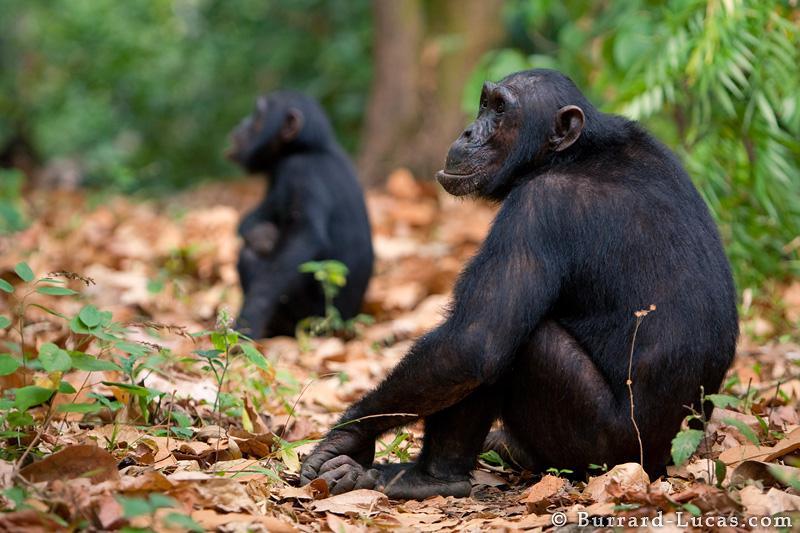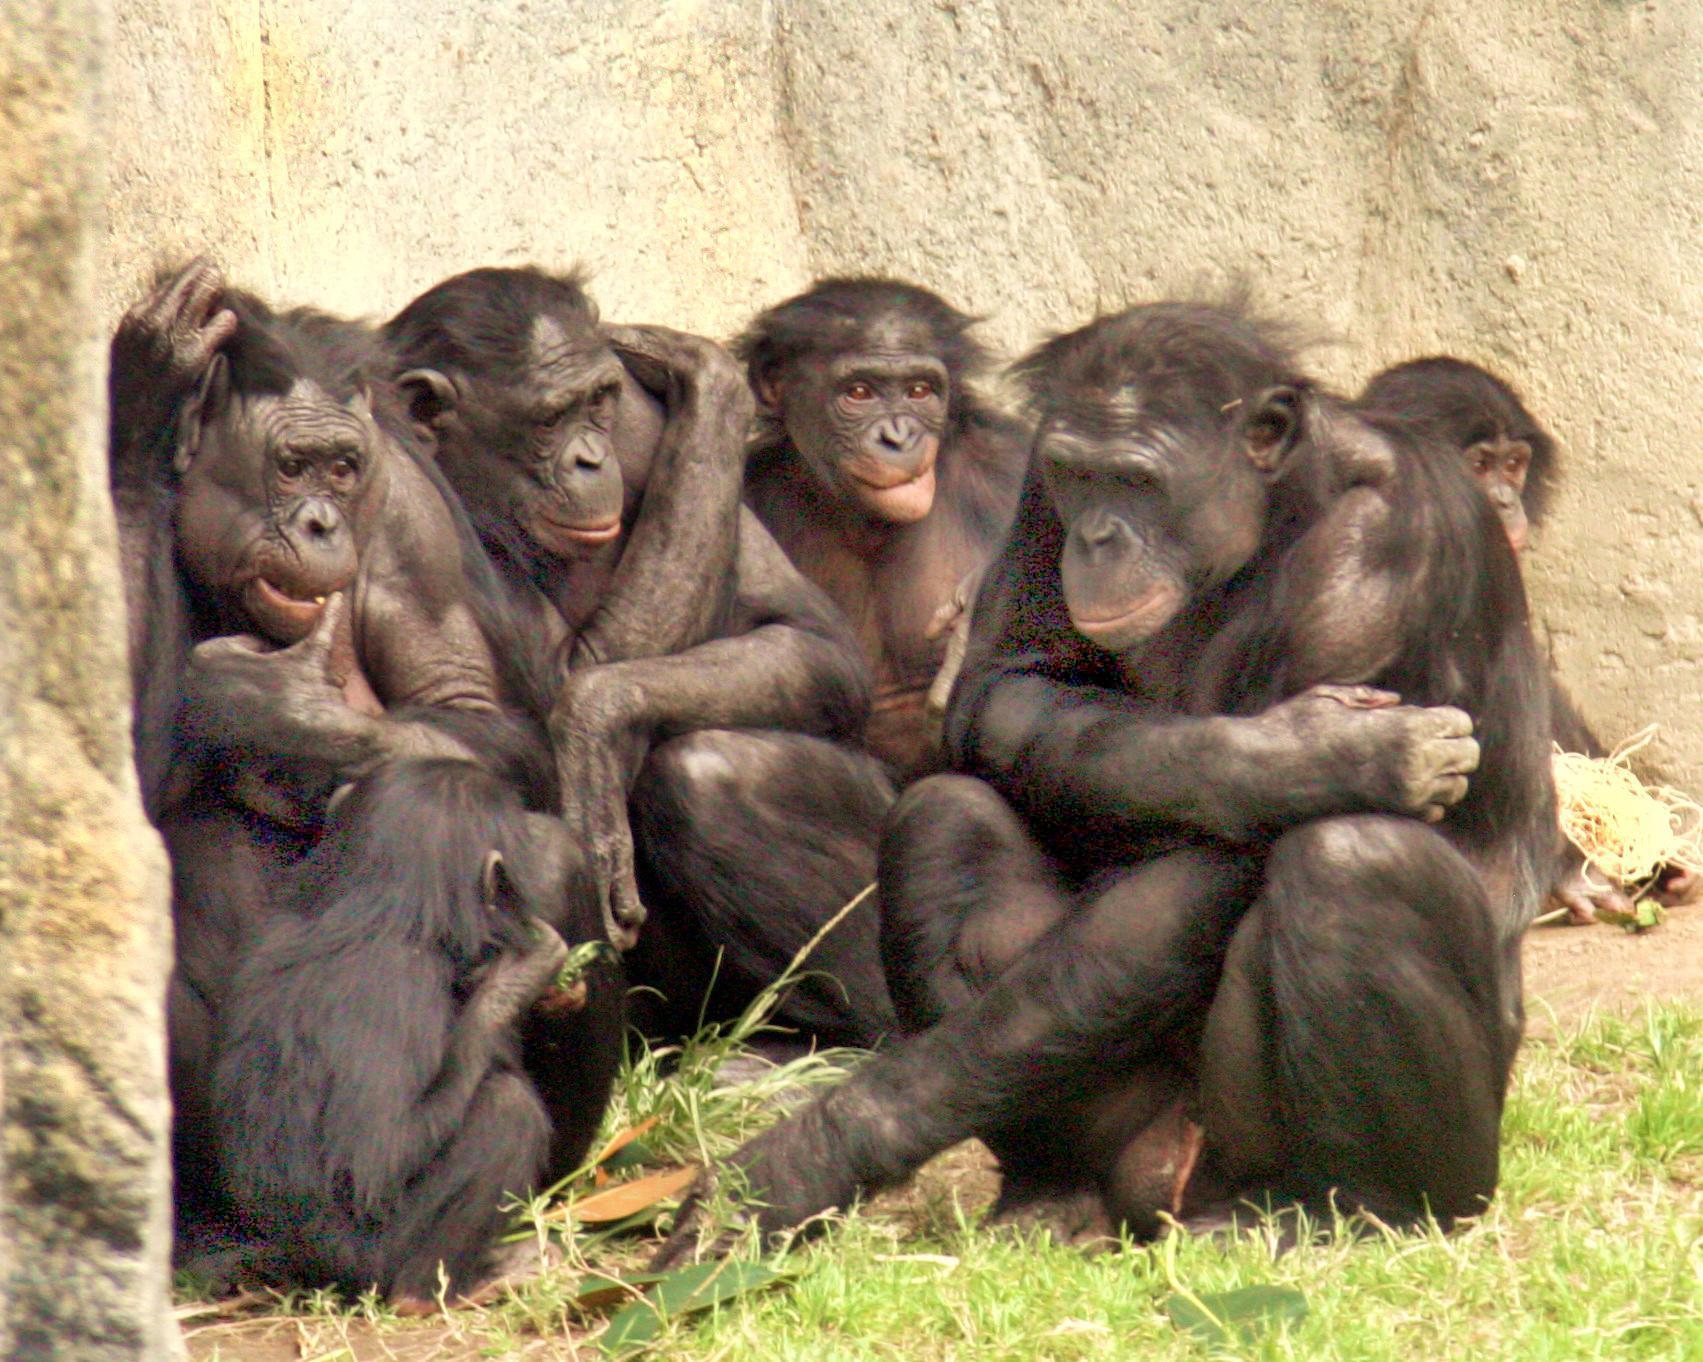The first image is the image on the left, the second image is the image on the right. Evaluate the accuracy of this statement regarding the images: "The right image contains exactly one chimpanzee.". Is it true? Answer yes or no. No. The first image is the image on the left, the second image is the image on the right. For the images shown, is this caption "One image includes exactly twice as many chimps as the other image." true? Answer yes or no. No. 